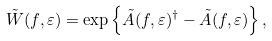Convert formula to latex. <formula><loc_0><loc_0><loc_500><loc_500>\tilde { W } ( f , \varepsilon ) = \exp \left \{ \tilde { A } ( f , \varepsilon ) ^ { \dag } - \tilde { A } ( f , \varepsilon ) \right \} ,</formula> 